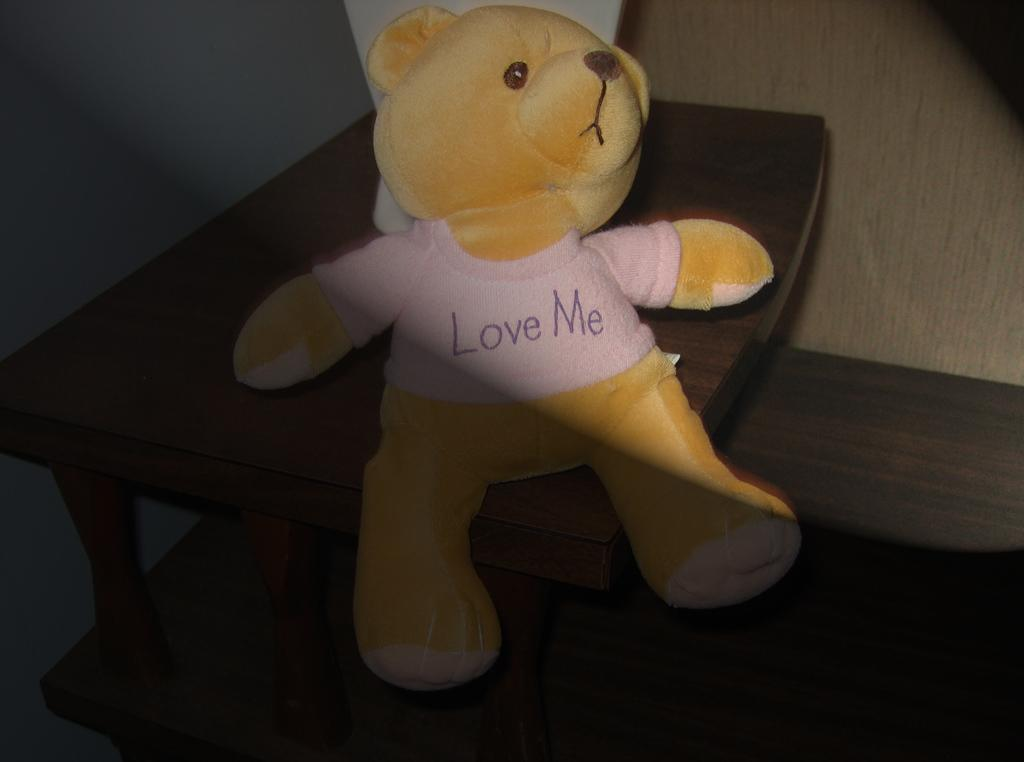What is placed on the table in the image? There is a doll on the table in the image. What other object can be seen on the table? There is a white object on the table in the image. What can be seen in the background of the image? There is a wall visible in the background of the image. What type of skate is being used to climb the wall in the image? There is no skate or climbing activity present in the image; it features a doll and a white object on a table with a wall visible in the background. 